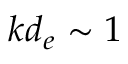<formula> <loc_0><loc_0><loc_500><loc_500>k d _ { e } \sim 1</formula> 